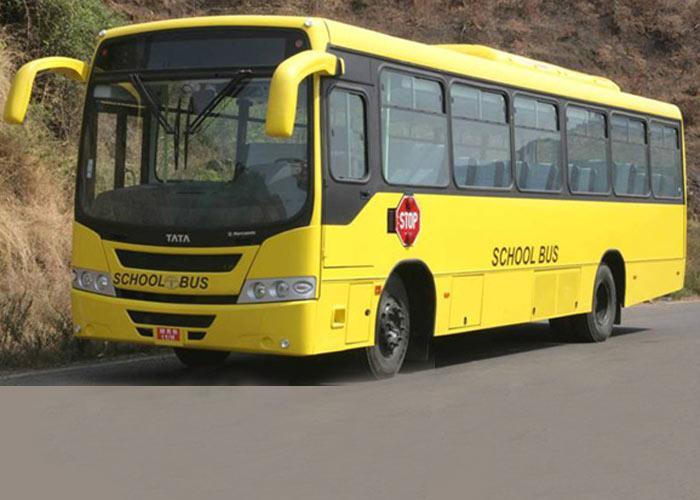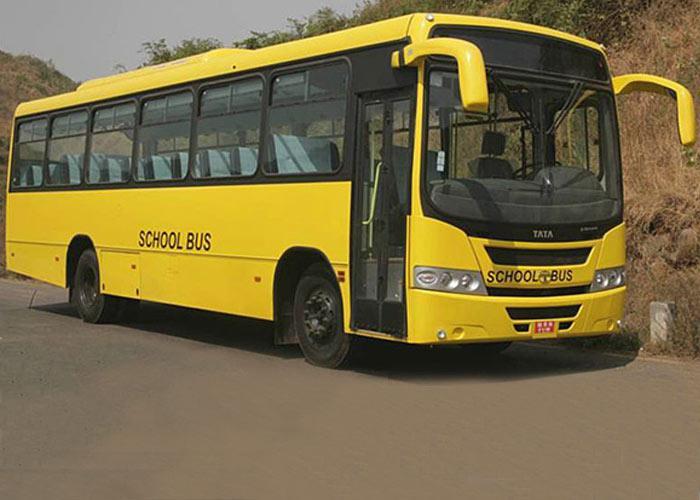The first image is the image on the left, the second image is the image on the right. Evaluate the accuracy of this statement regarding the images: "All images show flat-fronted buses parked at a forward angle, and at least one image features a bus with yellow downturned shapes on either side of the windshield.". Is it true? Answer yes or no. Yes. The first image is the image on the left, the second image is the image on the right. Assess this claim about the two images: "One of the pictures shows at least six school buses parked next to each other.". Correct or not? Answer yes or no. No. 